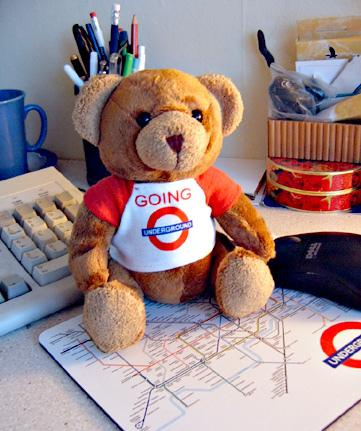What color is the big circular ring in the logo of the bear's t-shirt? red 